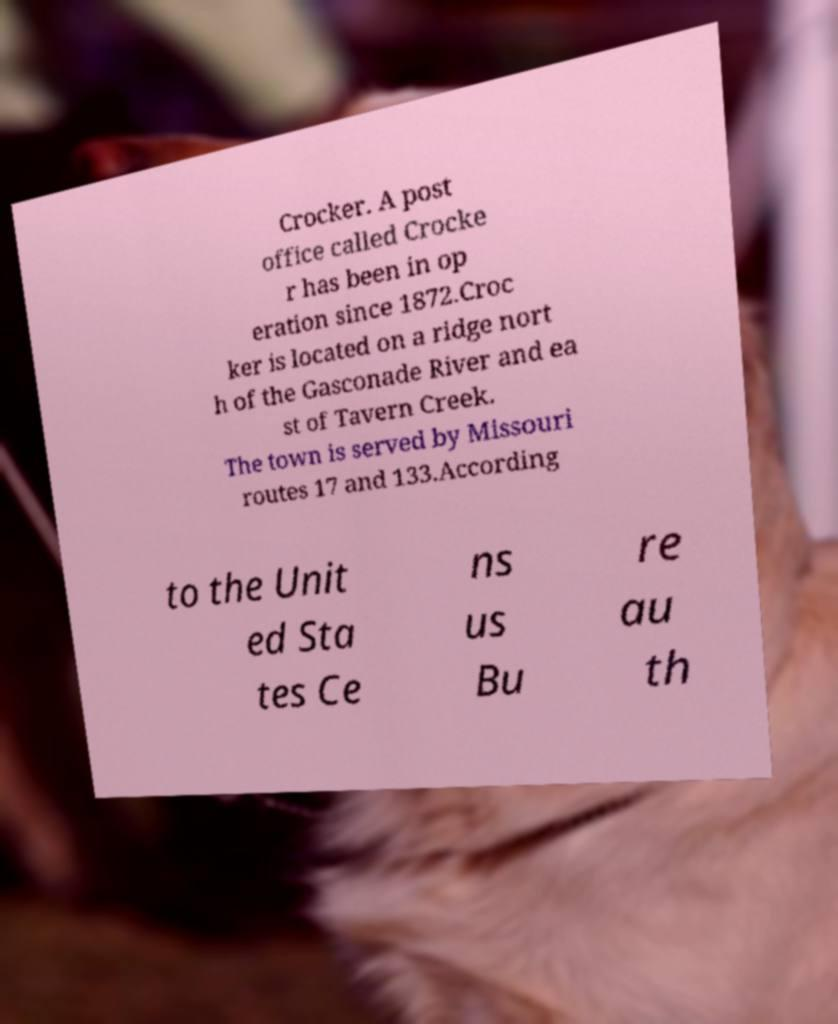What messages or text are displayed in this image? I need them in a readable, typed format. Crocker. A post office called Crocke r has been in op eration since 1872.Croc ker is located on a ridge nort h of the Gasconade River and ea st of Tavern Creek. The town is served by Missouri routes 17 and 133.According to the Unit ed Sta tes Ce ns us Bu re au th 